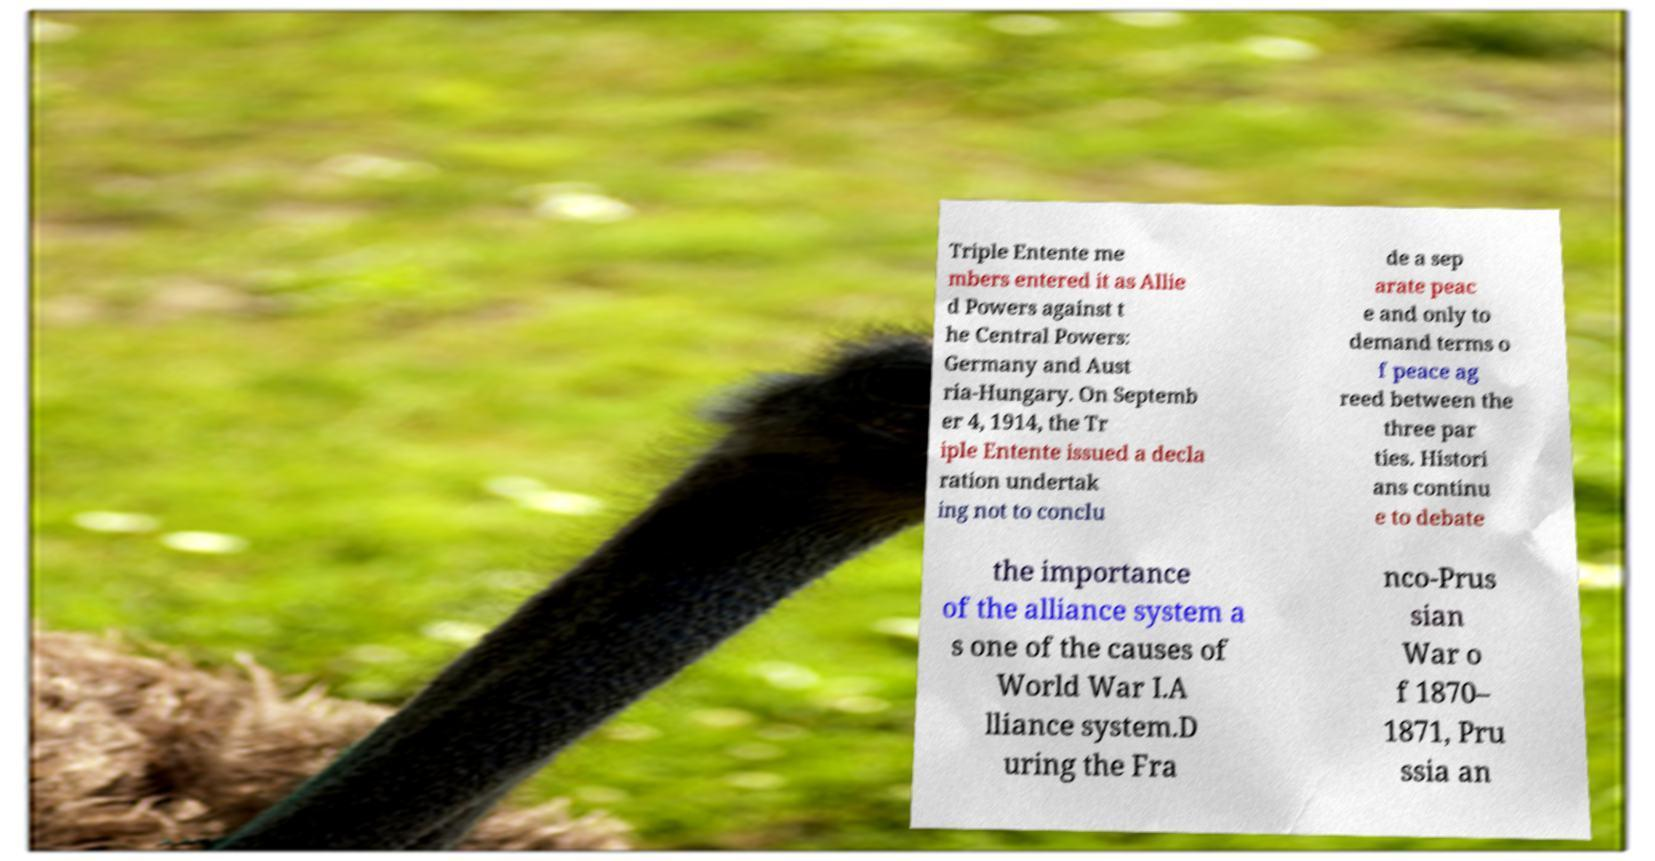Please identify and transcribe the text found in this image. Triple Entente me mbers entered it as Allie d Powers against t he Central Powers: Germany and Aust ria-Hungary. On Septemb er 4, 1914, the Tr iple Entente issued a decla ration undertak ing not to conclu de a sep arate peac e and only to demand terms o f peace ag reed between the three par ties. Histori ans continu e to debate the importance of the alliance system a s one of the causes of World War I.A lliance system.D uring the Fra nco-Prus sian War o f 1870– 1871, Pru ssia an 